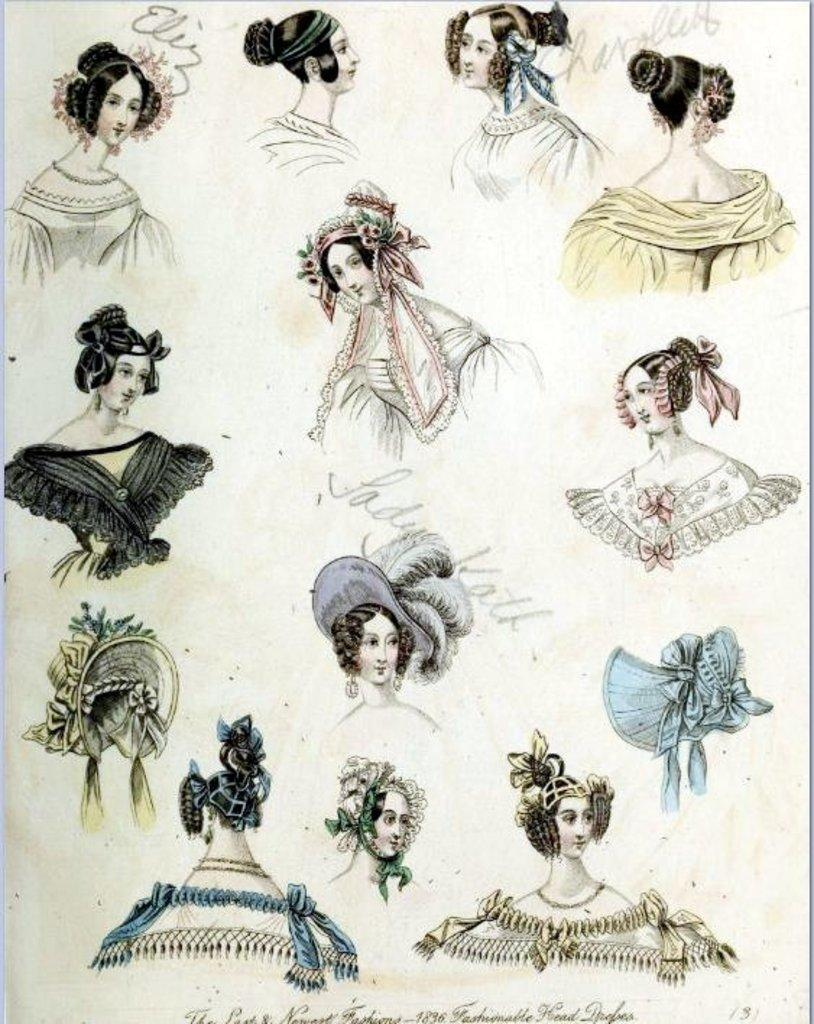What is featured in the image? There is a poster in the image. What type of images are on the poster? The poster contains cartoon images of women. Is there any text on the poster besides the images? Yes, there is a quotation at the bottom of the poster. How many loaves of bread are depicted in the cartoon images on the poster? There are no loaves of bread present in the cartoon images on the poster. 